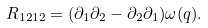<formula> <loc_0><loc_0><loc_500><loc_500>R _ { 1 2 1 2 } = ( \partial _ { 1 } \partial _ { 2 } - \partial _ { 2 } \partial _ { 1 } ) \omega ( q ) .</formula> 